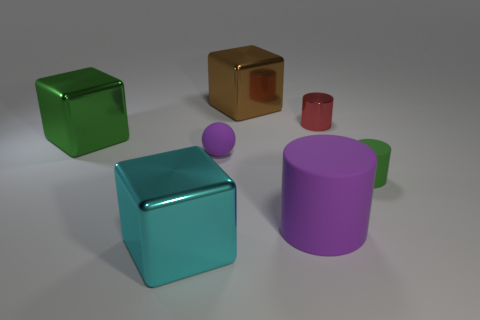Subtract all rubber cylinders. How many cylinders are left? 1 Add 3 blocks. How many objects exist? 10 Subtract 1 cubes. How many cubes are left? 2 Subtract all red cylinders. How many cylinders are left? 2 Subtract all cubes. How many objects are left? 4 Add 2 small matte spheres. How many small matte spheres exist? 3 Subtract 1 green cylinders. How many objects are left? 6 Subtract all gray cubes. Subtract all cyan cylinders. How many cubes are left? 3 Subtract all small matte balls. Subtract all purple matte things. How many objects are left? 4 Add 4 small matte objects. How many small matte objects are left? 6 